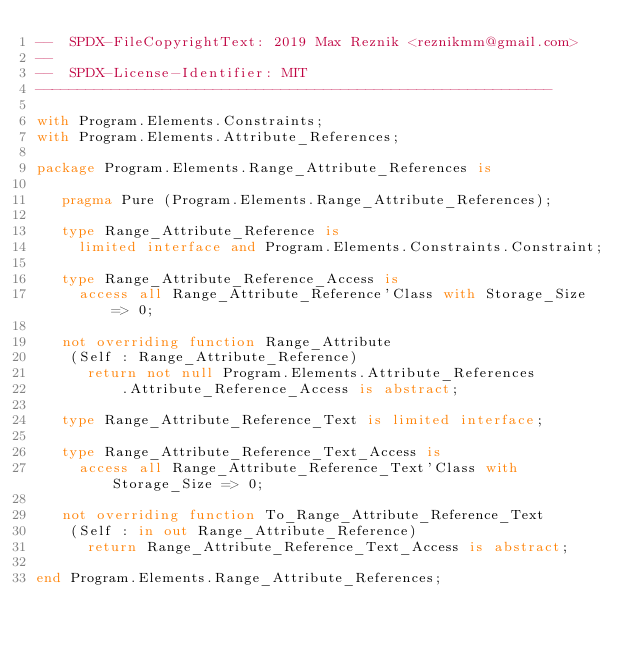Convert code to text. <code><loc_0><loc_0><loc_500><loc_500><_Ada_>--  SPDX-FileCopyrightText: 2019 Max Reznik <reznikmm@gmail.com>
--
--  SPDX-License-Identifier: MIT
-------------------------------------------------------------

with Program.Elements.Constraints;
with Program.Elements.Attribute_References;

package Program.Elements.Range_Attribute_References is

   pragma Pure (Program.Elements.Range_Attribute_References);

   type Range_Attribute_Reference is
     limited interface and Program.Elements.Constraints.Constraint;

   type Range_Attribute_Reference_Access is
     access all Range_Attribute_Reference'Class with Storage_Size => 0;

   not overriding function Range_Attribute
    (Self : Range_Attribute_Reference)
      return not null Program.Elements.Attribute_References
          .Attribute_Reference_Access is abstract;

   type Range_Attribute_Reference_Text is limited interface;

   type Range_Attribute_Reference_Text_Access is
     access all Range_Attribute_Reference_Text'Class with Storage_Size => 0;

   not overriding function To_Range_Attribute_Reference_Text
    (Self : in out Range_Attribute_Reference)
      return Range_Attribute_Reference_Text_Access is abstract;

end Program.Elements.Range_Attribute_References;
</code> 